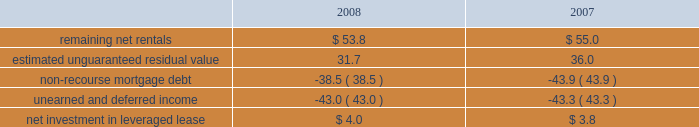Kimco realty corporation and subsidiaries notes to consolidated financial statements , continued investment in retail store leases the company has interests in various retail store leases relating to the anchor store premises in neighborhood and community shopping centers .
These premises have been sublet to retailers who lease the stores pursuant to net lease agreements .
Income from the investment in these retail store leases during the years ended december 31 , 2008 , 2007 and 2006 , was approximately $ 2.7 million , $ 1.2 million and $ 1.3 million , respectively .
These amounts represent sublease revenues during the years ended december 31 , 2008 , 2007 and 2006 , of approximately $ 7.1 million , $ 7.7 million and $ 8.2 million , respectively , less related expenses of $ 4.4 million , $ 5.1 million and $ 5.7 million , respectively , and an amount which , in management 2019s estimate , reasonably provides for the recovery of the investment over a period representing the expected remaining term of the retail store leases .
The company 2019s future minimum revenues under the terms of all non-cancelable tenant subleases and future minimum obligations through the remaining terms of its retail store leases , assuming no new or renegotiated leases are executed for such premises , for future years are as follows ( in millions ) : 2009 , $ 5.6 and $ 3.8 ; 2010 , $ 5.4 and $ 3.7 ; 2011 , $ 4.5 and $ 3.1 ; 2012 , $ 2.3 and $ 2.1 ; 2013 , $ 1.0 and $ 1.3 and thereafter , $ 1.4 and $ 0.5 , respectively .
Leveraged lease during june 2002 , the company acquired a 90% ( 90 % ) equity participation interest in an existing leveraged lease of 30 properties .
The properties are leased under a long-term bond-type net lease whose primary term expires in 2016 , with the lessee having certain renewal option rights .
The company 2019s cash equity investment was approximately $ 4.0 million .
This equity investment is reported as a net investment in leveraged lease in accordance with sfas no .
13 , accounting for leases ( as amended ) .
From 2002 to 2007 , 18 of these properties were sold , whereby the proceeds from the sales were used to pay down the mortgage debt by approximately $ 31.2 million .
As of december 31 , 2008 , the remaining 12 properties were encumbered by third-party non-recourse debt of approximately $ 42.8 million that is scheduled to fully amortize during the primary term of the lease from a portion of the periodic net rents receivable under the net lease .
As an equity participant in the leveraged lease , the company has no recourse obligation for principal or interest payments on the debt , which is collateralized by a first mortgage lien on the properties and collateral assignment of the lease .
Accordingly , this obligation has been offset against the related net rental receivable under the lease .
At december 31 , 2008 and 2007 , the company 2019s net investment in the leveraged lease consisted of the following ( in millions ) : .
Mortgages and other financing receivables : the company has various mortgages and other financing receivables which consist of loans acquired and loans originated by the company .
For a complete listing of the company 2019s mortgages and other financing receivables at december 31 , 2008 , see financial statement schedule iv included on page 141 of this annual report on form 10-k .
Reconciliation of mortgage loans and other financing receivables on real estate: .
What is the growth rate in the income from investment in the retail store leases from 2006 to 2007? 
Computations: ((1.2 - 1.3) / 1.3)
Answer: -0.07692. 